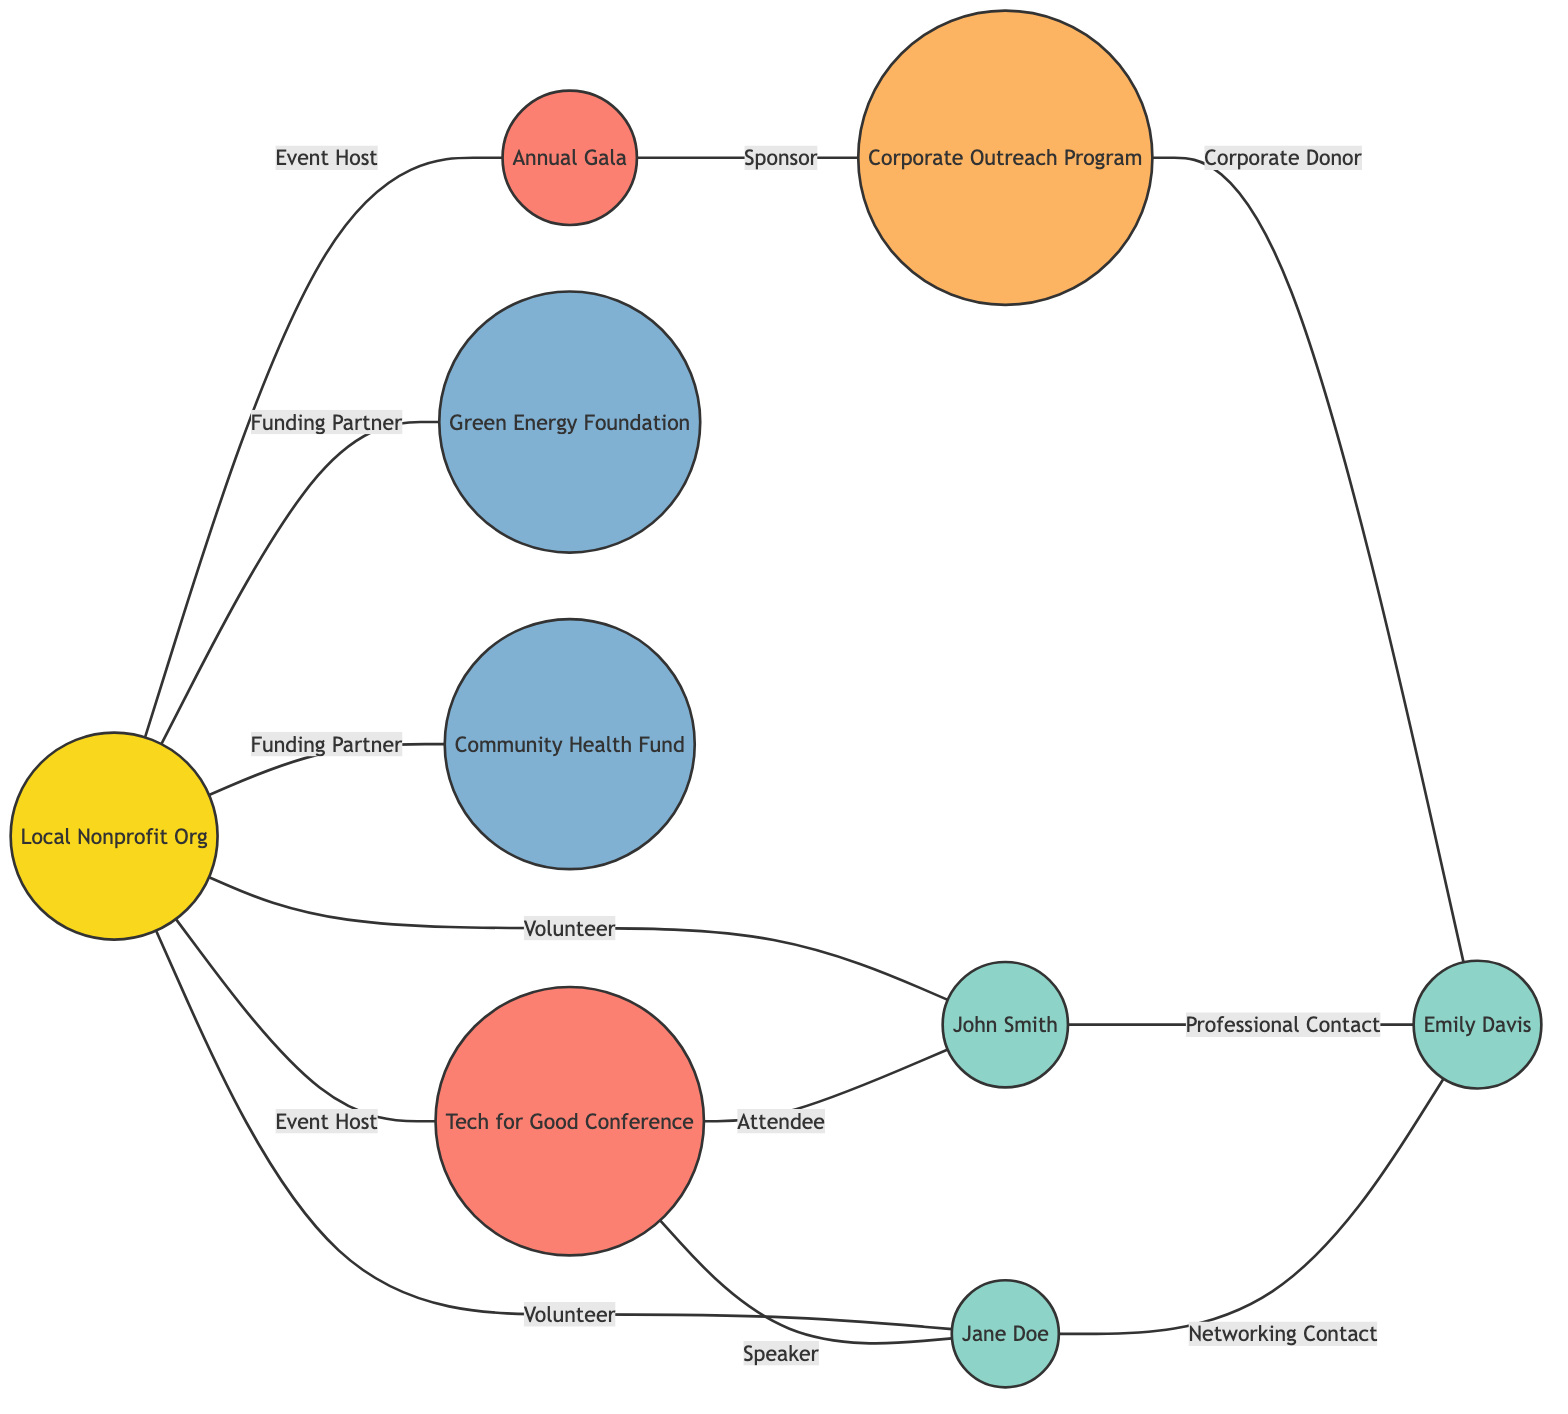What is the total number of nodes in the diagram? By counting the nodes listed in the data provided, there are 9 unique entities: Local Nonprofit Org, Jane Doe, John Smith, Tech for Good Conference, Green Energy Foundation, Community Health Fund, Annual Gala, Corporate Outreach Program, and Emily Davis.
Answer: 9 Who is the funding partner associated with the Local Nonprofit Org? The edges indicate that both Green Energy Foundation and Community Health Fund have a relationship labeled "Funding Partner" with the Local Nonprofit Org. Therefore, both are funding partners.
Answer: Green Energy Foundation, Community Health Fund What is the relationship between Jane Doe and Emily Davis? According to the edges presented, Jane Doe has a relationship labeled "Networking Contact" with Emily Davis, which indicates a professional connection between the two individuals.
Answer: Networking Contact How many volunteers are connected to the Local Nonprofit Org? The edges show two direct connections labeled "Volunteer" from the Local Nonprofit Org to Jane Doe and John Smith. Counting these edges, we find that there are a total of 2 volunteers.
Answer: 2 Which event does the Annual Gala connect to? The diagram shows an edge labeled "Sponsor" that connects the Annual Gala to the Corporate Outreach Program, indicating that the Annual Gala is financially supported or sponsored by this program.
Answer: Corporate Outreach Program What role does John Smith have in relation to the Tech for Good Conference? The diagram indicates that John Smith is labeled as an "Attendee" in connection to the Tech for Good Conference, meaning he participated in this event but did not play a speaking role.
Answer: Attendee Which individuals have a direct connection to Emily Davis? The edges indicate that both John Smith and Jane Doe have direct connections to Emily Davis, representing their distinct relationships with her, with John Smith labeled as "Professional Contact" and Jane Doe as "Networking Contact."
Answer: John Smith, Jane Doe What type of relationship exists between the Local Nonprofit Org and the Tech for Good Conference? The edge indicates that the Local Nonprofit Org has a relationship labeled "Event Host" with the Tech for Good Conference, illuminating its role in organizing or hosting this event.
Answer: Event Host What is the minimum number of edges directly associated with the Local Nonprofit Org? Upon reviewing the edges connected to the Local Nonprofit Org, it can be observed that there are a total of 5 edges associated with it: two for volunteers, two for funding partners, and one for event hosting, leading to a minimum count of edges.
Answer: 5 